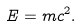<formula> <loc_0><loc_0><loc_500><loc_500>E = m c ^ { 2 } .</formula> 